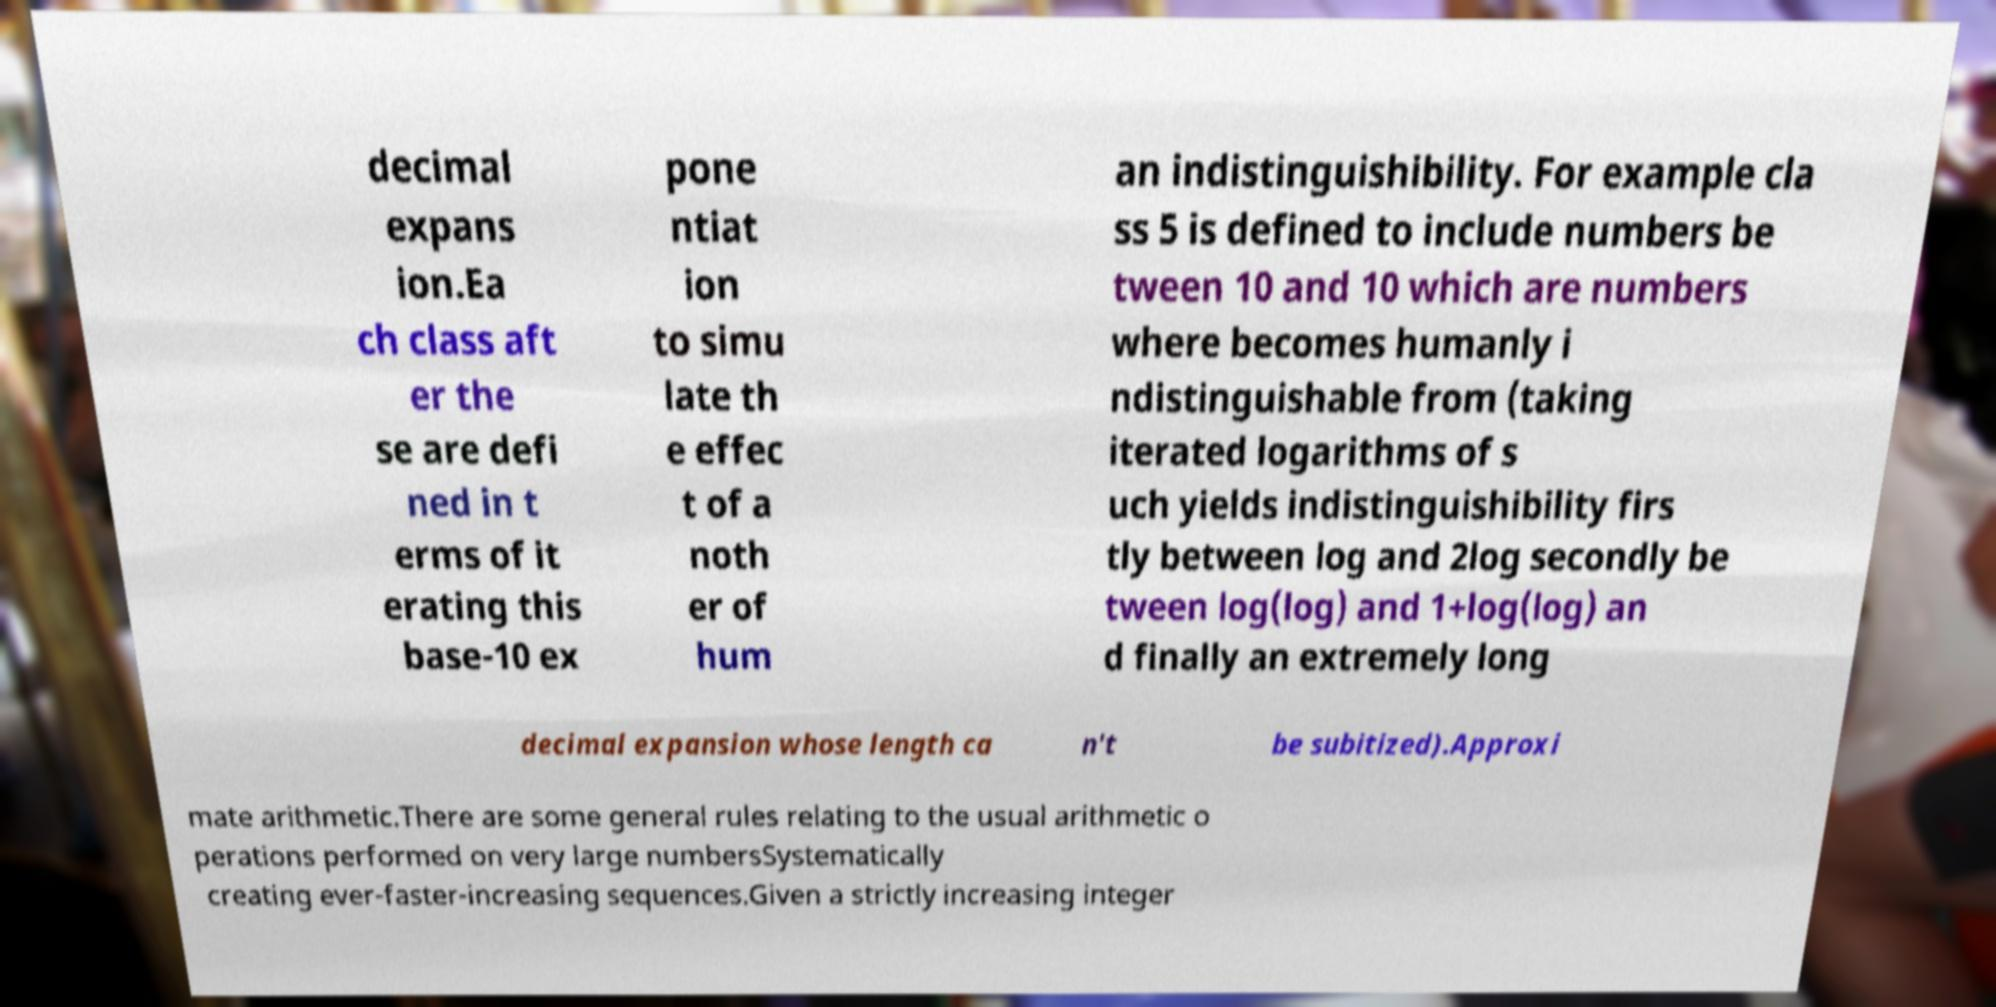Can you accurately transcribe the text from the provided image for me? decimal expans ion.Ea ch class aft er the se are defi ned in t erms of it erating this base-10 ex pone ntiat ion to simu late th e effec t of a noth er of hum an indistinguishibility. For example cla ss 5 is defined to include numbers be tween 10 and 10 which are numbers where becomes humanly i ndistinguishable from (taking iterated logarithms of s uch yields indistinguishibility firs tly between log and 2log secondly be tween log(log) and 1+log(log) an d finally an extremely long decimal expansion whose length ca n't be subitized).Approxi mate arithmetic.There are some general rules relating to the usual arithmetic o perations performed on very large numbersSystematically creating ever-faster-increasing sequences.Given a strictly increasing integer 